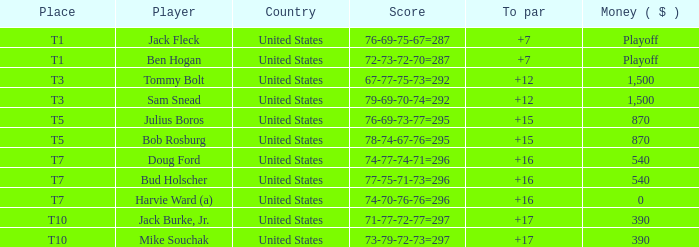When bud holscher is playing, what is his average score compared to par? 16.0. 